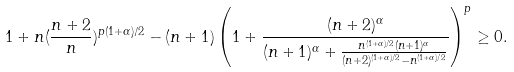Convert formula to latex. <formula><loc_0><loc_0><loc_500><loc_500>1 + n ( \frac { n + 2 } { n } ) ^ { p ( 1 + \alpha ) / 2 } - ( n + 1 ) \left ( 1 + \frac { ( n + 2 ) ^ { \alpha } } { ( n + 1 ) ^ { \alpha } + \frac { n ^ { ( 1 + \alpha ) / 2 } ( n + 1 ) ^ { \alpha } } { ( n + 2 ) ^ { ( 1 + \alpha ) / 2 } - n ^ { ( 1 + \alpha ) / 2 } } } \right ) ^ { p } \geq 0 .</formula> 